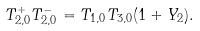Convert formula to latex. <formula><loc_0><loc_0><loc_500><loc_500>T _ { 2 , 0 } ^ { + } T _ { 2 , 0 } ^ { - } = T _ { 1 , 0 } T _ { 3 , 0 } ( 1 + Y _ { 2 } ) .</formula> 